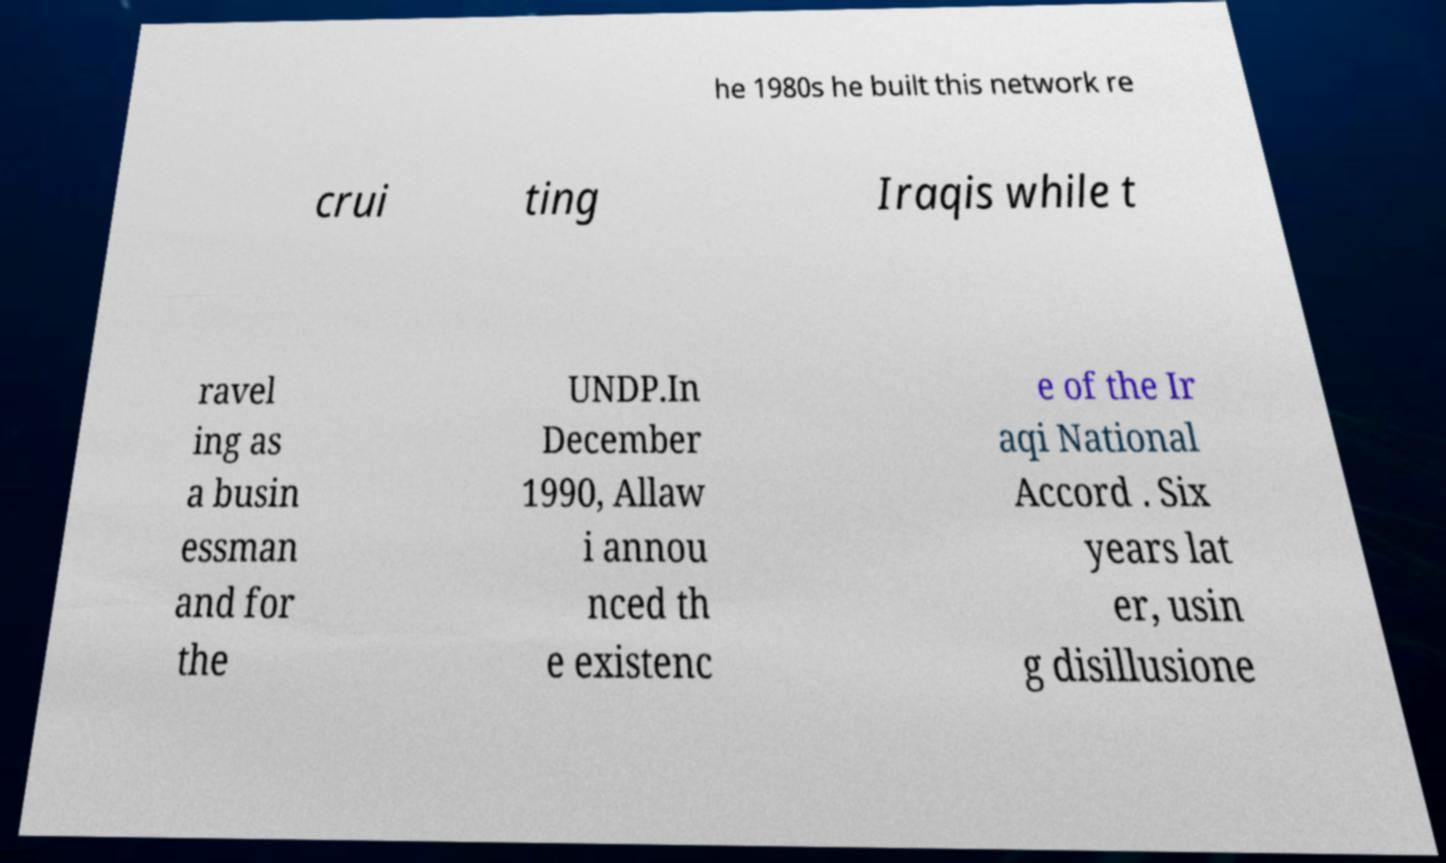Could you assist in decoding the text presented in this image and type it out clearly? he 1980s he built this network re crui ting Iraqis while t ravel ing as a busin essman and for the UNDP.In December 1990, Allaw i annou nced th e existenc e of the Ir aqi National Accord . Six years lat er, usin g disillusione 